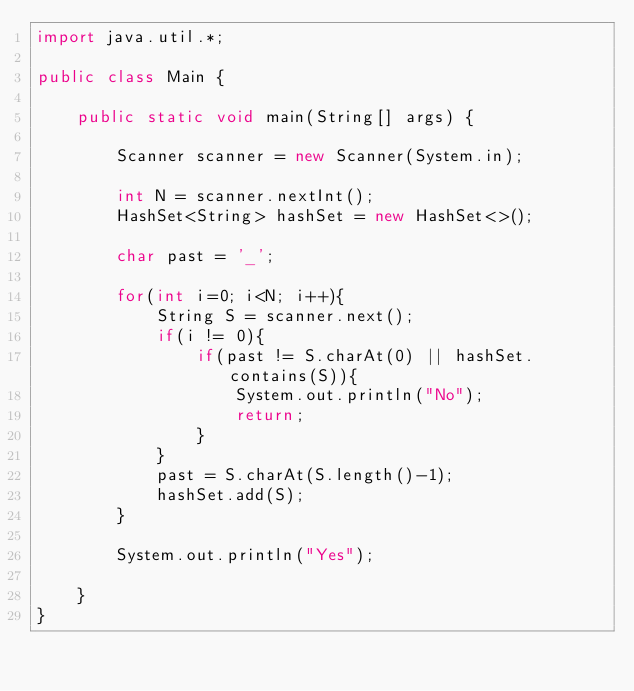<code> <loc_0><loc_0><loc_500><loc_500><_Java_>import java.util.*;

public class Main {

    public static void main(String[] args) {

        Scanner scanner = new Scanner(System.in);

        int N = scanner.nextInt();
        HashSet<String> hashSet = new HashSet<>();

        char past = '_';

        for(int i=0; i<N; i++){
            String S = scanner.next();
            if(i != 0){
                if(past != S.charAt(0) || hashSet.contains(S)){
                    System.out.println("No");
                    return;
                }
            }
            past = S.charAt(S.length()-1);
            hashSet.add(S);
        }

        System.out.println("Yes");

    }
}
</code> 